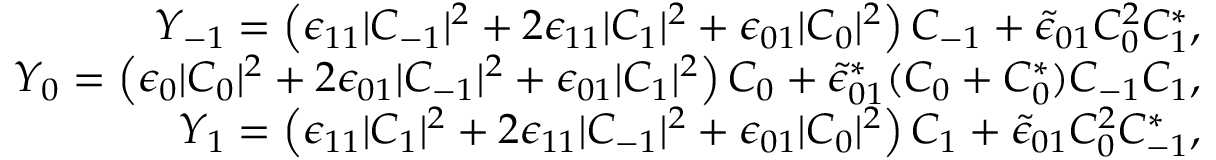Convert formula to latex. <formula><loc_0><loc_0><loc_500><loc_500>\begin{array} { r l r } & { Y _ { - 1 } = \left ( \epsilon _ { 1 1 } | C _ { - 1 } | ^ { 2 } + 2 \epsilon _ { 1 1 } | C _ { 1 } | ^ { 2 } + \epsilon _ { 0 1 } | C _ { 0 } | ^ { 2 } \right ) C _ { - 1 } + \tilde { \epsilon } _ { 0 1 } C _ { 0 } ^ { 2 } C _ { 1 } ^ { * } , } \\ & { Y _ { 0 } = \left ( \epsilon _ { 0 } | C _ { 0 } | ^ { 2 } + 2 \epsilon _ { 0 1 } | C _ { - 1 } | ^ { 2 } + \epsilon _ { 0 1 } | C _ { 1 } | ^ { 2 } \right ) C _ { 0 } + \tilde { \epsilon } _ { 0 1 } ^ { * } ( C _ { 0 } + C _ { 0 } ^ { * } ) C _ { - 1 } C _ { 1 } , } \\ & { Y _ { 1 } = \left ( \epsilon _ { 1 1 } | C _ { 1 } | ^ { 2 } + 2 \epsilon _ { 1 1 } | C _ { - 1 } | ^ { 2 } + \epsilon _ { 0 1 } | C _ { 0 } | ^ { 2 } \right ) C _ { 1 } + \tilde { \epsilon } _ { 0 1 } C _ { 0 } ^ { 2 } C _ { - 1 } ^ { * } , } \end{array}</formula> 